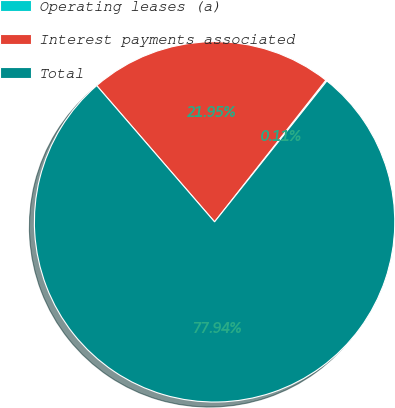Convert chart to OTSL. <chart><loc_0><loc_0><loc_500><loc_500><pie_chart><fcel>Operating leases (a)<fcel>Interest payments associated<fcel>Total<nl><fcel>0.11%<fcel>21.95%<fcel>77.95%<nl></chart> 